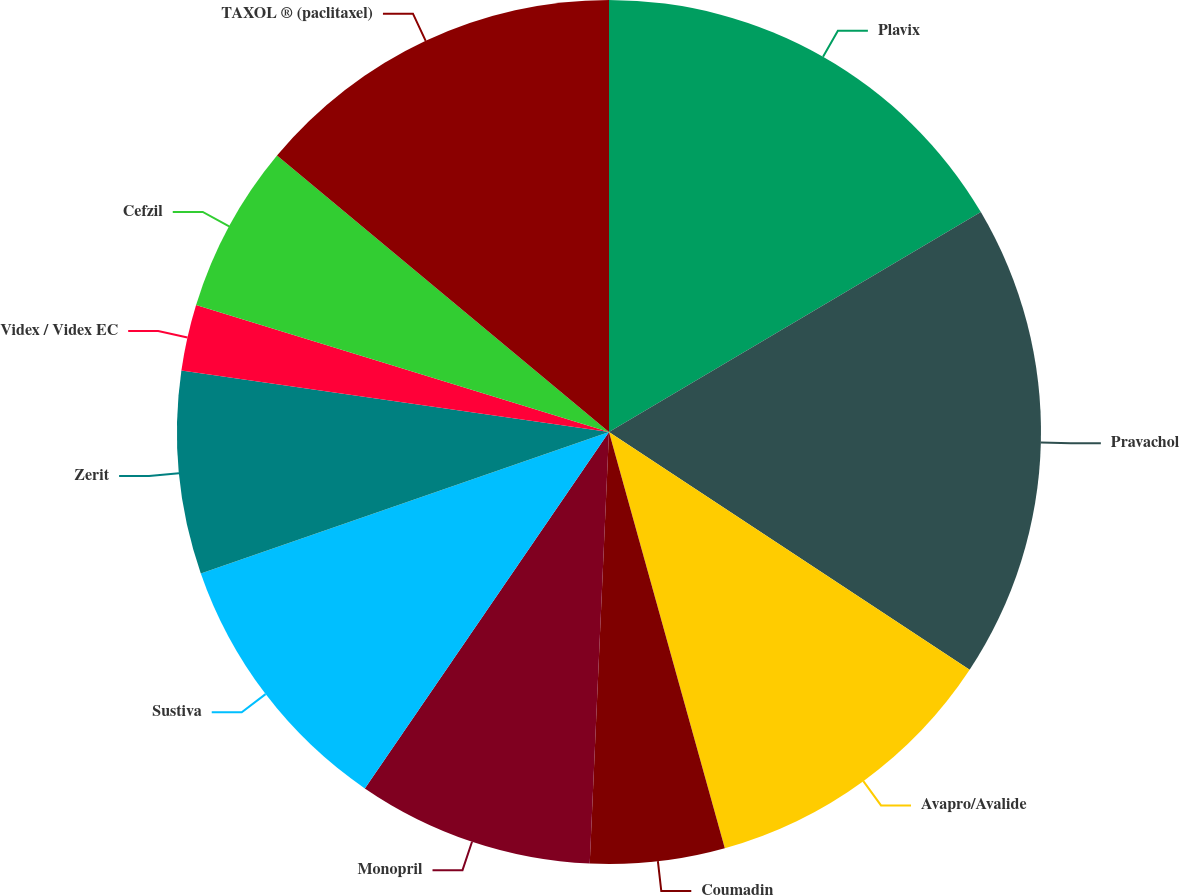Convert chart. <chart><loc_0><loc_0><loc_500><loc_500><pie_chart><fcel>Plavix<fcel>Pravachol<fcel>Avapro/Avalide<fcel>Coumadin<fcel>Monopril<fcel>Sustiva<fcel>Zerit<fcel>Videx / Videx EC<fcel>Cefzil<fcel>TAXOL ® (paclitaxel)<nl><fcel>16.5%<fcel>17.78%<fcel>11.4%<fcel>5.03%<fcel>8.85%<fcel>10.13%<fcel>7.58%<fcel>2.48%<fcel>6.3%<fcel>13.95%<nl></chart> 